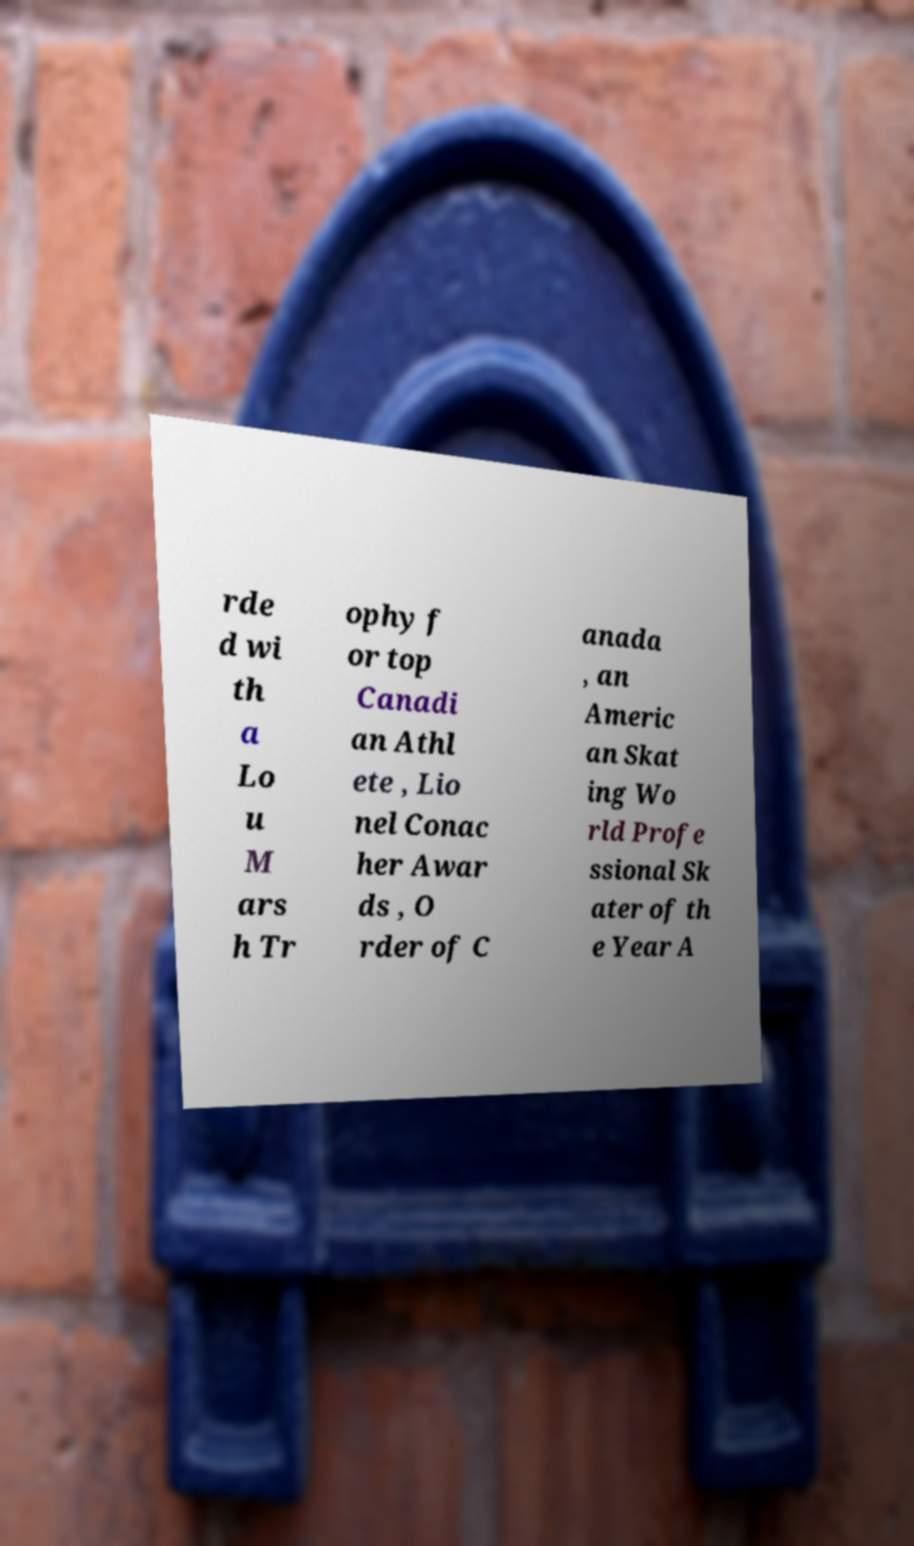Can you read and provide the text displayed in the image?This photo seems to have some interesting text. Can you extract and type it out for me? rde d wi th a Lo u M ars h Tr ophy f or top Canadi an Athl ete , Lio nel Conac her Awar ds , O rder of C anada , an Americ an Skat ing Wo rld Profe ssional Sk ater of th e Year A 